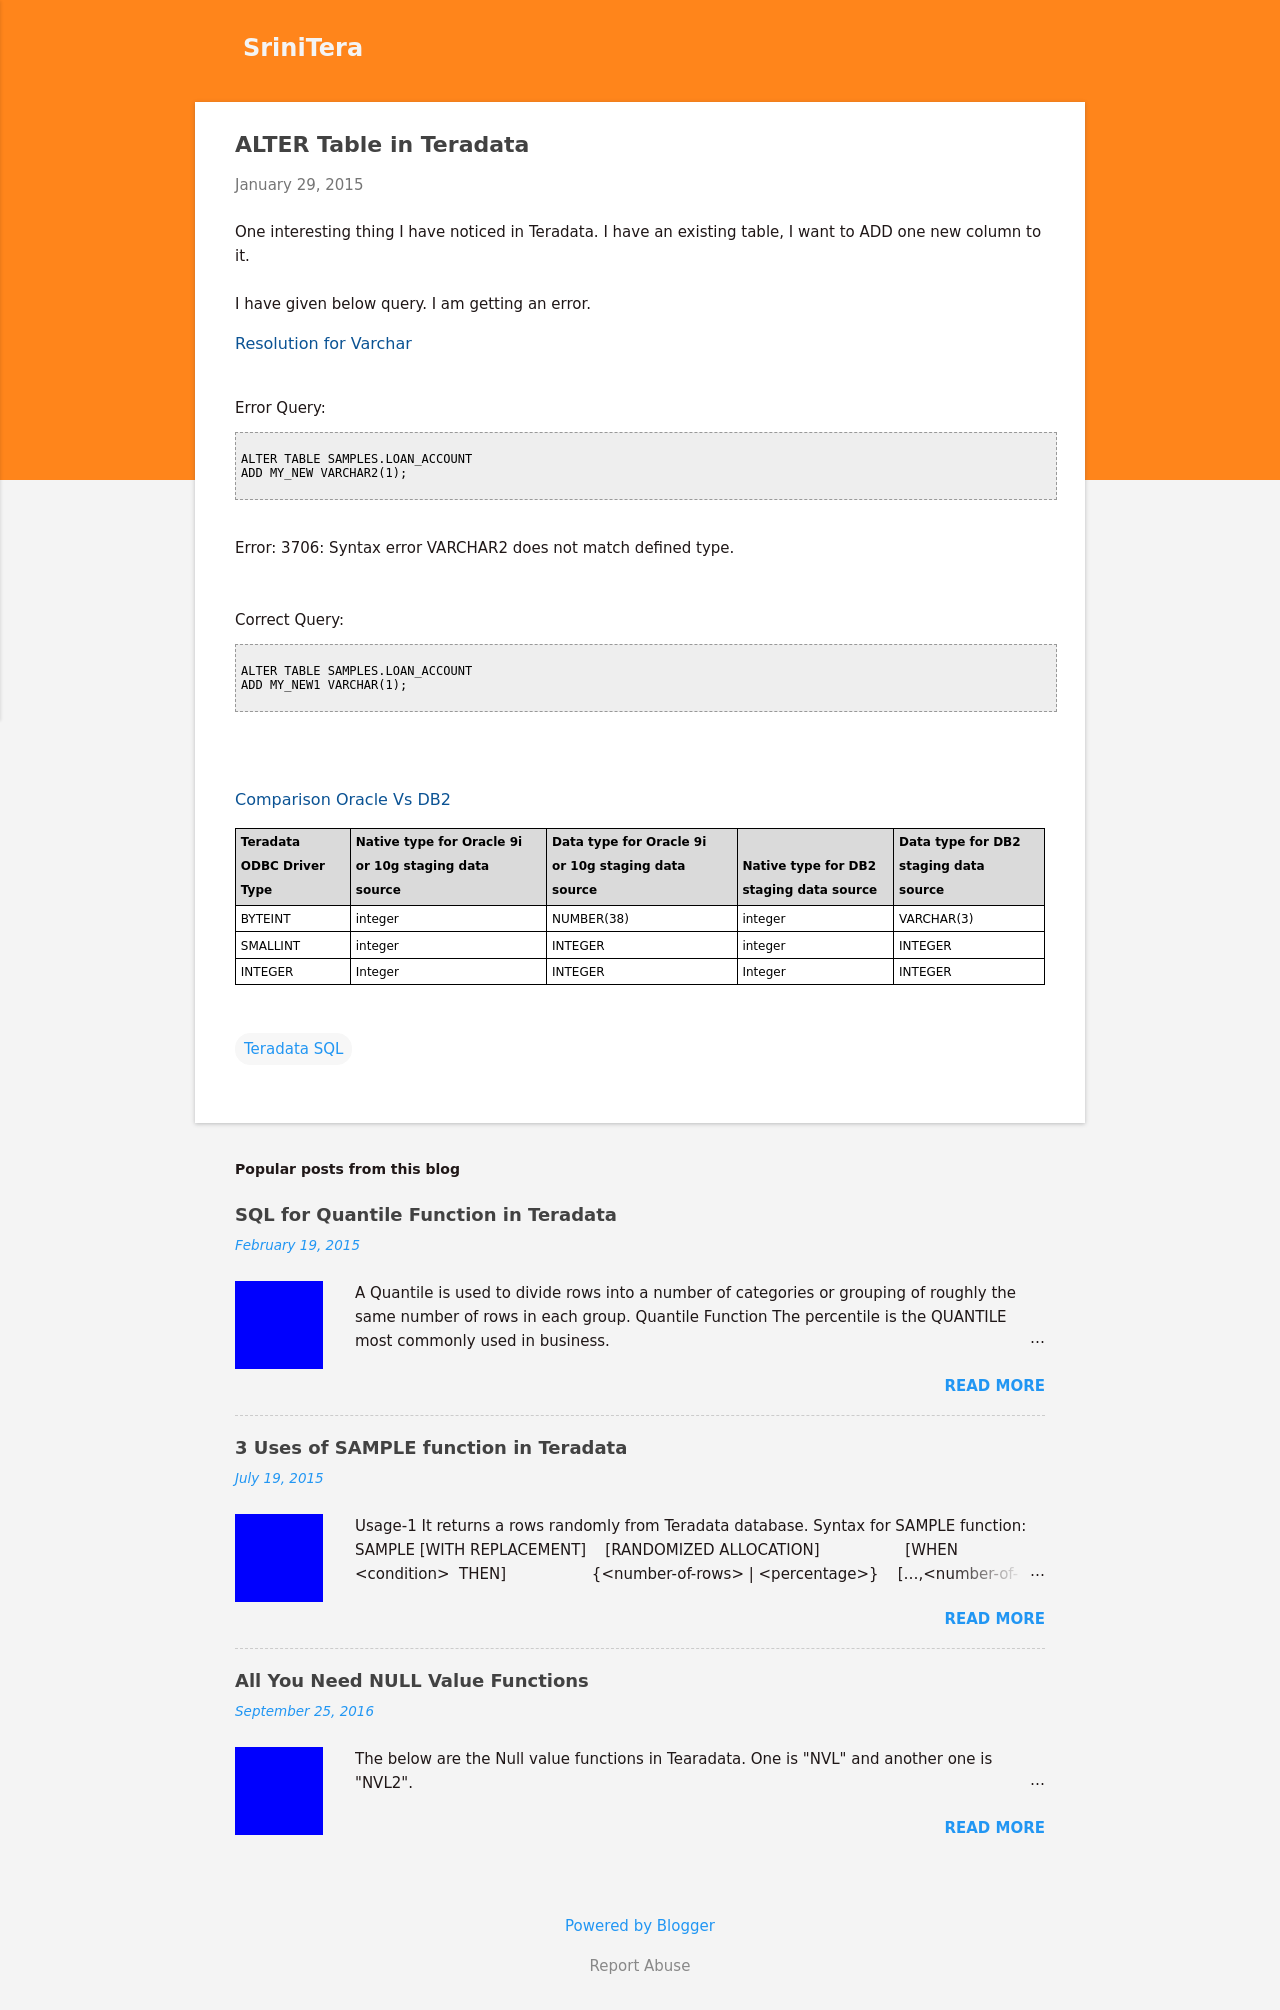What is the main topic discussed in this blog post? The main topic discussed in this blog post is about modifying an existing table in Teradata by adding a new column, and it also addresses a common error associated with this task. Additionally, there's information on datatype comparisons between Teradata, Oracle, and DB2.  Can you explain more about the error mentioned in the blog post? Certainly! The mentioned error '3706: Syntax error VARCHAR2 does not match defined type' occurs when attempting to add a column with a datatype (VARCHAR2) that is not supported. Teradata uses VARCHAR instead of VARCHAR2, which is typically used in Oracle databases. 